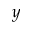<formula> <loc_0><loc_0><loc_500><loc_500>y</formula> 